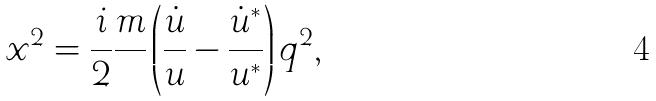<formula> <loc_0><loc_0><loc_500><loc_500>x ^ { 2 } = \frac { i } { 2 } \frac { m } { } \left ( \frac { \dot { u } } { u } - \frac { \dot { u } ^ { * } } { u ^ { * } } \right ) q ^ { 2 } ,</formula> 